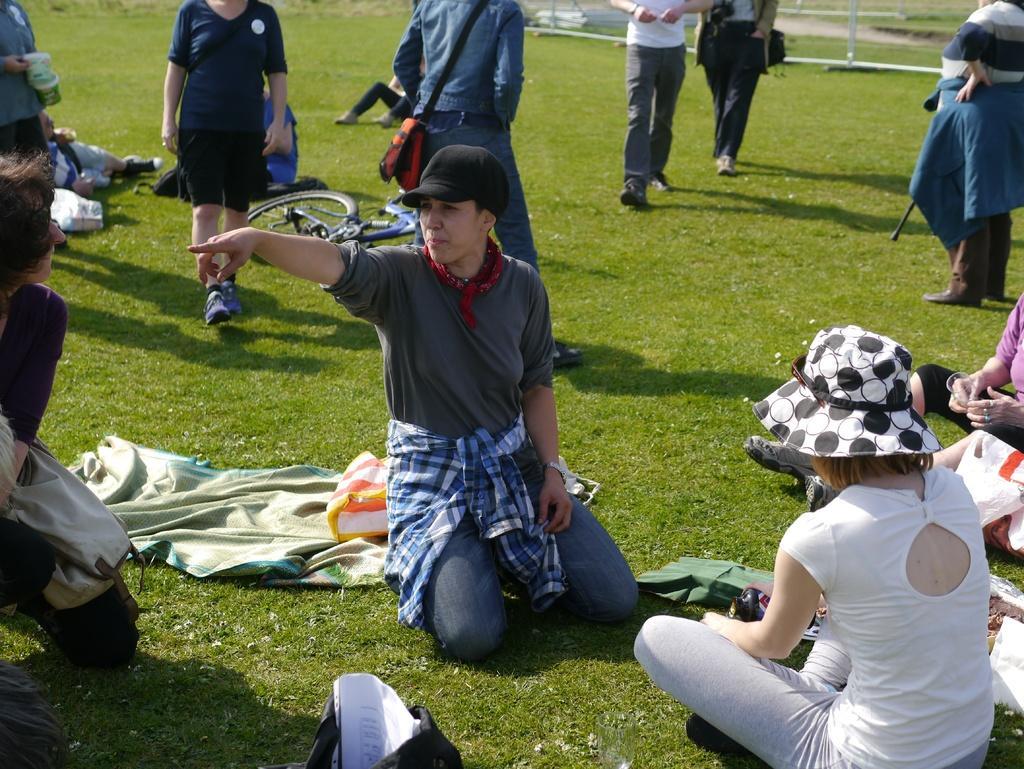Can you describe this image briefly? This image is taken outdoors. At the bottom of the image there is a ground with grass on it. In the middle of the image a man is sitting on the ground and there is a cloth on the ground. On the left and right sides of the image a few people are sitting on the ground and a few are standing on the ground. In the background there is a bicycle on the ground and a few people are walking on the ground. 